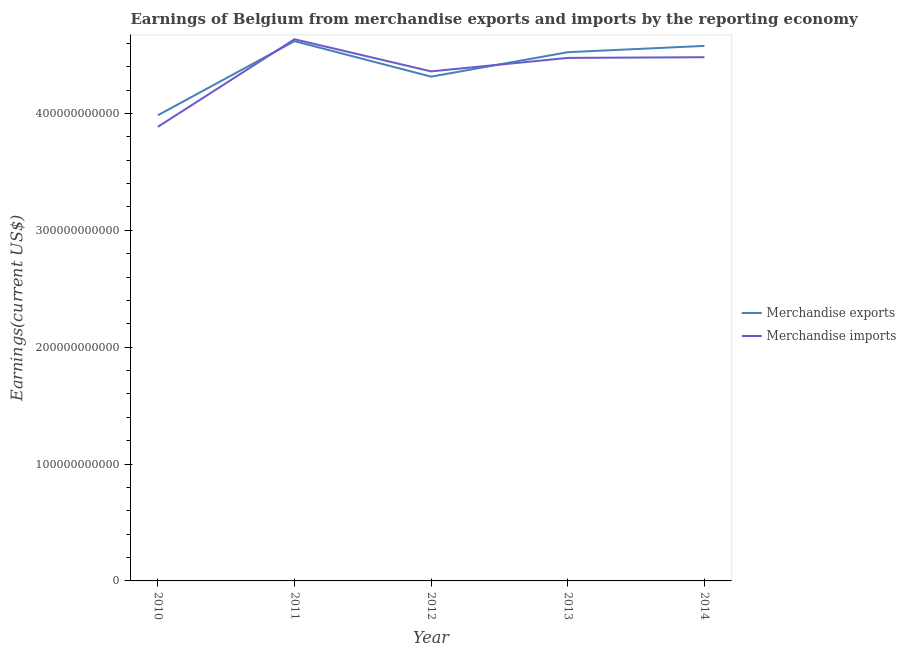Is the number of lines equal to the number of legend labels?
Provide a short and direct response. Yes. What is the earnings from merchandise exports in 2011?
Make the answer very short. 4.62e+11. Across all years, what is the maximum earnings from merchandise imports?
Your answer should be compact. 4.63e+11. Across all years, what is the minimum earnings from merchandise exports?
Your answer should be compact. 3.98e+11. In which year was the earnings from merchandise exports minimum?
Provide a short and direct response. 2010. What is the total earnings from merchandise imports in the graph?
Your answer should be very brief. 2.18e+12. What is the difference between the earnings from merchandise imports in 2013 and that in 2014?
Offer a very short reply. -5.87e+08. What is the difference between the earnings from merchandise exports in 2010 and the earnings from merchandise imports in 2011?
Your response must be concise. -6.50e+1. What is the average earnings from merchandise imports per year?
Your response must be concise. 4.37e+11. In the year 2012, what is the difference between the earnings from merchandise exports and earnings from merchandise imports?
Keep it short and to the point. -4.52e+09. What is the ratio of the earnings from merchandise imports in 2011 to that in 2012?
Give a very brief answer. 1.06. Is the difference between the earnings from merchandise exports in 2011 and 2013 greater than the difference between the earnings from merchandise imports in 2011 and 2013?
Provide a succinct answer. No. What is the difference between the highest and the second highest earnings from merchandise imports?
Ensure brevity in your answer.  1.54e+1. What is the difference between the highest and the lowest earnings from merchandise exports?
Keep it short and to the point. 6.34e+1. In how many years, is the earnings from merchandise imports greater than the average earnings from merchandise imports taken over all years?
Offer a very short reply. 3. Does the earnings from merchandise exports monotonically increase over the years?
Your response must be concise. No. What is the difference between two consecutive major ticks on the Y-axis?
Make the answer very short. 1.00e+11. Does the graph contain any zero values?
Your answer should be very brief. No. Does the graph contain grids?
Offer a terse response. No. How many legend labels are there?
Ensure brevity in your answer.  2. How are the legend labels stacked?
Make the answer very short. Vertical. What is the title of the graph?
Ensure brevity in your answer.  Earnings of Belgium from merchandise exports and imports by the reporting economy. Does "Borrowers" appear as one of the legend labels in the graph?
Keep it short and to the point. No. What is the label or title of the Y-axis?
Give a very brief answer. Earnings(current US$). What is the Earnings(current US$) in Merchandise exports in 2010?
Offer a terse response. 3.98e+11. What is the Earnings(current US$) of Merchandise imports in 2010?
Offer a terse response. 3.89e+11. What is the Earnings(current US$) in Merchandise exports in 2011?
Make the answer very short. 4.62e+11. What is the Earnings(current US$) of Merchandise imports in 2011?
Ensure brevity in your answer.  4.63e+11. What is the Earnings(current US$) of Merchandise exports in 2012?
Provide a short and direct response. 4.31e+11. What is the Earnings(current US$) in Merchandise imports in 2012?
Make the answer very short. 4.36e+11. What is the Earnings(current US$) in Merchandise exports in 2013?
Offer a very short reply. 4.52e+11. What is the Earnings(current US$) of Merchandise imports in 2013?
Your response must be concise. 4.47e+11. What is the Earnings(current US$) in Merchandise exports in 2014?
Ensure brevity in your answer.  4.58e+11. What is the Earnings(current US$) in Merchandise imports in 2014?
Make the answer very short. 4.48e+11. Across all years, what is the maximum Earnings(current US$) in Merchandise exports?
Ensure brevity in your answer.  4.62e+11. Across all years, what is the maximum Earnings(current US$) in Merchandise imports?
Offer a very short reply. 4.63e+11. Across all years, what is the minimum Earnings(current US$) of Merchandise exports?
Provide a succinct answer. 3.98e+11. Across all years, what is the minimum Earnings(current US$) in Merchandise imports?
Make the answer very short. 3.89e+11. What is the total Earnings(current US$) of Merchandise exports in the graph?
Make the answer very short. 2.20e+12. What is the total Earnings(current US$) in Merchandise imports in the graph?
Your answer should be very brief. 2.18e+12. What is the difference between the Earnings(current US$) in Merchandise exports in 2010 and that in 2011?
Keep it short and to the point. -6.34e+1. What is the difference between the Earnings(current US$) of Merchandise imports in 2010 and that in 2011?
Your response must be concise. -7.49e+1. What is the difference between the Earnings(current US$) of Merchandise exports in 2010 and that in 2012?
Your response must be concise. -3.30e+1. What is the difference between the Earnings(current US$) of Merchandise imports in 2010 and that in 2012?
Your answer should be compact. -4.74e+1. What is the difference between the Earnings(current US$) in Merchandise exports in 2010 and that in 2013?
Offer a terse response. -5.40e+1. What is the difference between the Earnings(current US$) in Merchandise imports in 2010 and that in 2013?
Provide a succinct answer. -5.90e+1. What is the difference between the Earnings(current US$) in Merchandise exports in 2010 and that in 2014?
Your response must be concise. -5.94e+1. What is the difference between the Earnings(current US$) of Merchandise imports in 2010 and that in 2014?
Provide a succinct answer. -5.96e+1. What is the difference between the Earnings(current US$) in Merchandise exports in 2011 and that in 2012?
Offer a terse response. 3.04e+1. What is the difference between the Earnings(current US$) in Merchandise imports in 2011 and that in 2012?
Offer a terse response. 2.75e+1. What is the difference between the Earnings(current US$) in Merchandise exports in 2011 and that in 2013?
Ensure brevity in your answer.  9.45e+09. What is the difference between the Earnings(current US$) of Merchandise imports in 2011 and that in 2013?
Offer a terse response. 1.60e+1. What is the difference between the Earnings(current US$) in Merchandise exports in 2011 and that in 2014?
Offer a very short reply. 4.06e+09. What is the difference between the Earnings(current US$) of Merchandise imports in 2011 and that in 2014?
Your answer should be compact. 1.54e+1. What is the difference between the Earnings(current US$) in Merchandise exports in 2012 and that in 2013?
Provide a short and direct response. -2.09e+1. What is the difference between the Earnings(current US$) in Merchandise imports in 2012 and that in 2013?
Your answer should be very brief. -1.15e+1. What is the difference between the Earnings(current US$) in Merchandise exports in 2012 and that in 2014?
Provide a succinct answer. -2.63e+1. What is the difference between the Earnings(current US$) in Merchandise imports in 2012 and that in 2014?
Make the answer very short. -1.21e+1. What is the difference between the Earnings(current US$) in Merchandise exports in 2013 and that in 2014?
Provide a short and direct response. -5.39e+09. What is the difference between the Earnings(current US$) in Merchandise imports in 2013 and that in 2014?
Make the answer very short. -5.87e+08. What is the difference between the Earnings(current US$) of Merchandise exports in 2010 and the Earnings(current US$) of Merchandise imports in 2011?
Your answer should be very brief. -6.50e+1. What is the difference between the Earnings(current US$) of Merchandise exports in 2010 and the Earnings(current US$) of Merchandise imports in 2012?
Your response must be concise. -3.76e+1. What is the difference between the Earnings(current US$) in Merchandise exports in 2010 and the Earnings(current US$) in Merchandise imports in 2013?
Provide a succinct answer. -4.91e+1. What is the difference between the Earnings(current US$) of Merchandise exports in 2010 and the Earnings(current US$) of Merchandise imports in 2014?
Ensure brevity in your answer.  -4.97e+1. What is the difference between the Earnings(current US$) in Merchandise exports in 2011 and the Earnings(current US$) in Merchandise imports in 2012?
Offer a very short reply. 2.59e+1. What is the difference between the Earnings(current US$) of Merchandise exports in 2011 and the Earnings(current US$) of Merchandise imports in 2013?
Your response must be concise. 1.43e+1. What is the difference between the Earnings(current US$) of Merchandise exports in 2011 and the Earnings(current US$) of Merchandise imports in 2014?
Your answer should be compact. 1.37e+1. What is the difference between the Earnings(current US$) in Merchandise exports in 2012 and the Earnings(current US$) in Merchandise imports in 2013?
Your answer should be compact. -1.60e+1. What is the difference between the Earnings(current US$) in Merchandise exports in 2012 and the Earnings(current US$) in Merchandise imports in 2014?
Make the answer very short. -1.66e+1. What is the difference between the Earnings(current US$) in Merchandise exports in 2013 and the Earnings(current US$) in Merchandise imports in 2014?
Provide a succinct answer. 4.30e+09. What is the average Earnings(current US$) in Merchandise exports per year?
Your answer should be very brief. 4.40e+11. What is the average Earnings(current US$) in Merchandise imports per year?
Offer a very short reply. 4.37e+11. In the year 2010, what is the difference between the Earnings(current US$) in Merchandise exports and Earnings(current US$) in Merchandise imports?
Keep it short and to the point. 9.89e+09. In the year 2011, what is the difference between the Earnings(current US$) of Merchandise exports and Earnings(current US$) of Merchandise imports?
Offer a terse response. -1.62e+09. In the year 2012, what is the difference between the Earnings(current US$) of Merchandise exports and Earnings(current US$) of Merchandise imports?
Offer a very short reply. -4.52e+09. In the year 2013, what is the difference between the Earnings(current US$) of Merchandise exports and Earnings(current US$) of Merchandise imports?
Give a very brief answer. 4.89e+09. In the year 2014, what is the difference between the Earnings(current US$) in Merchandise exports and Earnings(current US$) in Merchandise imports?
Offer a terse response. 9.69e+09. What is the ratio of the Earnings(current US$) in Merchandise exports in 2010 to that in 2011?
Give a very brief answer. 0.86. What is the ratio of the Earnings(current US$) of Merchandise imports in 2010 to that in 2011?
Keep it short and to the point. 0.84. What is the ratio of the Earnings(current US$) in Merchandise exports in 2010 to that in 2012?
Your response must be concise. 0.92. What is the ratio of the Earnings(current US$) in Merchandise imports in 2010 to that in 2012?
Provide a short and direct response. 0.89. What is the ratio of the Earnings(current US$) of Merchandise exports in 2010 to that in 2013?
Ensure brevity in your answer.  0.88. What is the ratio of the Earnings(current US$) of Merchandise imports in 2010 to that in 2013?
Provide a short and direct response. 0.87. What is the ratio of the Earnings(current US$) in Merchandise exports in 2010 to that in 2014?
Offer a terse response. 0.87. What is the ratio of the Earnings(current US$) in Merchandise imports in 2010 to that in 2014?
Your response must be concise. 0.87. What is the ratio of the Earnings(current US$) in Merchandise exports in 2011 to that in 2012?
Your answer should be very brief. 1.07. What is the ratio of the Earnings(current US$) of Merchandise imports in 2011 to that in 2012?
Make the answer very short. 1.06. What is the ratio of the Earnings(current US$) of Merchandise exports in 2011 to that in 2013?
Offer a terse response. 1.02. What is the ratio of the Earnings(current US$) of Merchandise imports in 2011 to that in 2013?
Provide a succinct answer. 1.04. What is the ratio of the Earnings(current US$) of Merchandise exports in 2011 to that in 2014?
Provide a succinct answer. 1.01. What is the ratio of the Earnings(current US$) of Merchandise imports in 2011 to that in 2014?
Ensure brevity in your answer.  1.03. What is the ratio of the Earnings(current US$) in Merchandise exports in 2012 to that in 2013?
Ensure brevity in your answer.  0.95. What is the ratio of the Earnings(current US$) of Merchandise imports in 2012 to that in 2013?
Give a very brief answer. 0.97. What is the ratio of the Earnings(current US$) of Merchandise exports in 2012 to that in 2014?
Offer a very short reply. 0.94. What is the ratio of the Earnings(current US$) of Merchandise imports in 2012 to that in 2014?
Give a very brief answer. 0.97. What is the ratio of the Earnings(current US$) of Merchandise exports in 2013 to that in 2014?
Your response must be concise. 0.99. What is the difference between the highest and the second highest Earnings(current US$) of Merchandise exports?
Make the answer very short. 4.06e+09. What is the difference between the highest and the second highest Earnings(current US$) of Merchandise imports?
Give a very brief answer. 1.54e+1. What is the difference between the highest and the lowest Earnings(current US$) in Merchandise exports?
Provide a succinct answer. 6.34e+1. What is the difference between the highest and the lowest Earnings(current US$) of Merchandise imports?
Your answer should be very brief. 7.49e+1. 